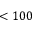<formula> <loc_0><loc_0><loc_500><loc_500>< 1 0 0</formula> 